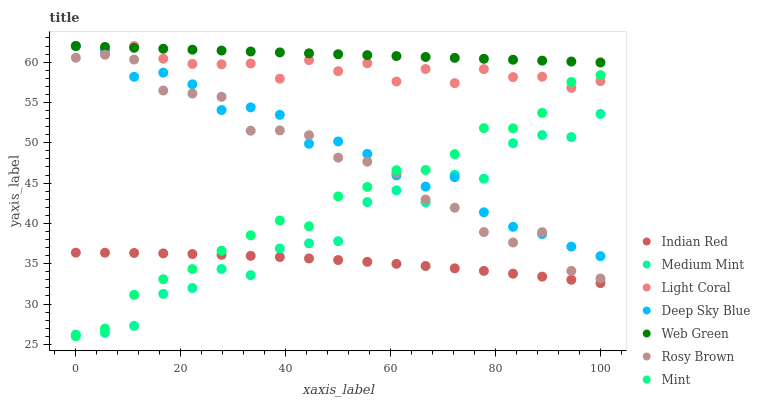Does Indian Red have the minimum area under the curve?
Answer yes or no. Yes. Does Web Green have the maximum area under the curve?
Answer yes or no. Yes. Does Rosy Brown have the minimum area under the curve?
Answer yes or no. No. Does Rosy Brown have the maximum area under the curve?
Answer yes or no. No. Is Web Green the smoothest?
Answer yes or no. Yes. Is Medium Mint the roughest?
Answer yes or no. Yes. Is Indian Red the smoothest?
Answer yes or no. No. Is Indian Red the roughest?
Answer yes or no. No. Does Mint have the lowest value?
Answer yes or no. Yes. Does Indian Red have the lowest value?
Answer yes or no. No. Does Deep Sky Blue have the highest value?
Answer yes or no. Yes. Does Rosy Brown have the highest value?
Answer yes or no. No. Is Medium Mint less than Web Green?
Answer yes or no. Yes. Is Web Green greater than Indian Red?
Answer yes or no. Yes. Does Mint intersect Deep Sky Blue?
Answer yes or no. Yes. Is Mint less than Deep Sky Blue?
Answer yes or no. No. Is Mint greater than Deep Sky Blue?
Answer yes or no. No. Does Medium Mint intersect Web Green?
Answer yes or no. No. 